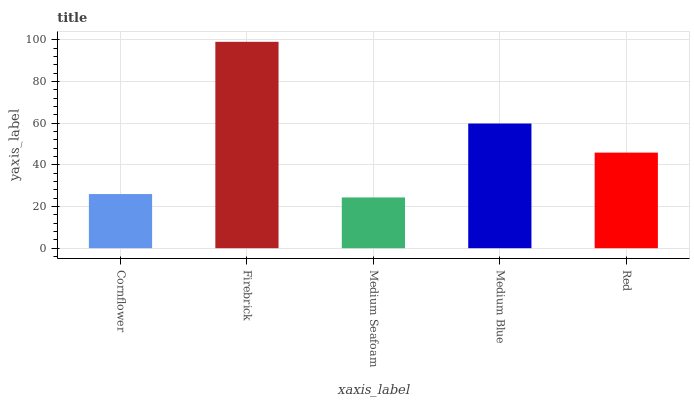Is Medium Seafoam the minimum?
Answer yes or no. Yes. Is Firebrick the maximum?
Answer yes or no. Yes. Is Firebrick the minimum?
Answer yes or no. No. Is Medium Seafoam the maximum?
Answer yes or no. No. Is Firebrick greater than Medium Seafoam?
Answer yes or no. Yes. Is Medium Seafoam less than Firebrick?
Answer yes or no. Yes. Is Medium Seafoam greater than Firebrick?
Answer yes or no. No. Is Firebrick less than Medium Seafoam?
Answer yes or no. No. Is Red the high median?
Answer yes or no. Yes. Is Red the low median?
Answer yes or no. Yes. Is Firebrick the high median?
Answer yes or no. No. Is Firebrick the low median?
Answer yes or no. No. 